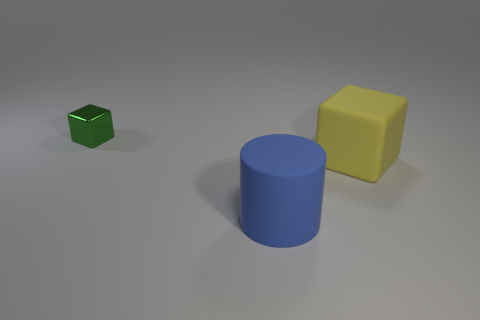Add 3 yellow rubber objects. How many objects exist? 6 Subtract all cubes. How many objects are left? 1 Subtract all large yellow blocks. Subtract all matte objects. How many objects are left? 0 Add 2 big yellow matte blocks. How many big yellow matte blocks are left? 3 Add 2 shiny blocks. How many shiny blocks exist? 3 Subtract 0 gray balls. How many objects are left? 3 